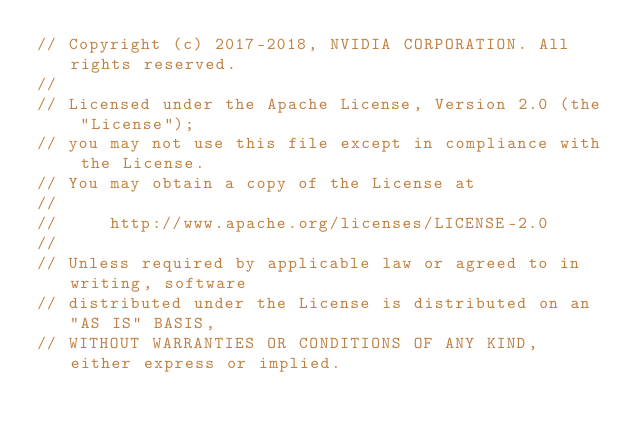Convert code to text. <code><loc_0><loc_0><loc_500><loc_500><_Cuda_>// Copyright (c) 2017-2018, NVIDIA CORPORATION. All rights reserved.
//
// Licensed under the Apache License, Version 2.0 (the "License");
// you may not use this file except in compliance with the License.
// You may obtain a copy of the License at
//
//     http://www.apache.org/licenses/LICENSE-2.0
//
// Unless required by applicable law or agreed to in writing, software
// distributed under the License is distributed on an "AS IS" BASIS,
// WITHOUT WARRANTIES OR CONDITIONS OF ANY KIND, either express or implied.</code> 